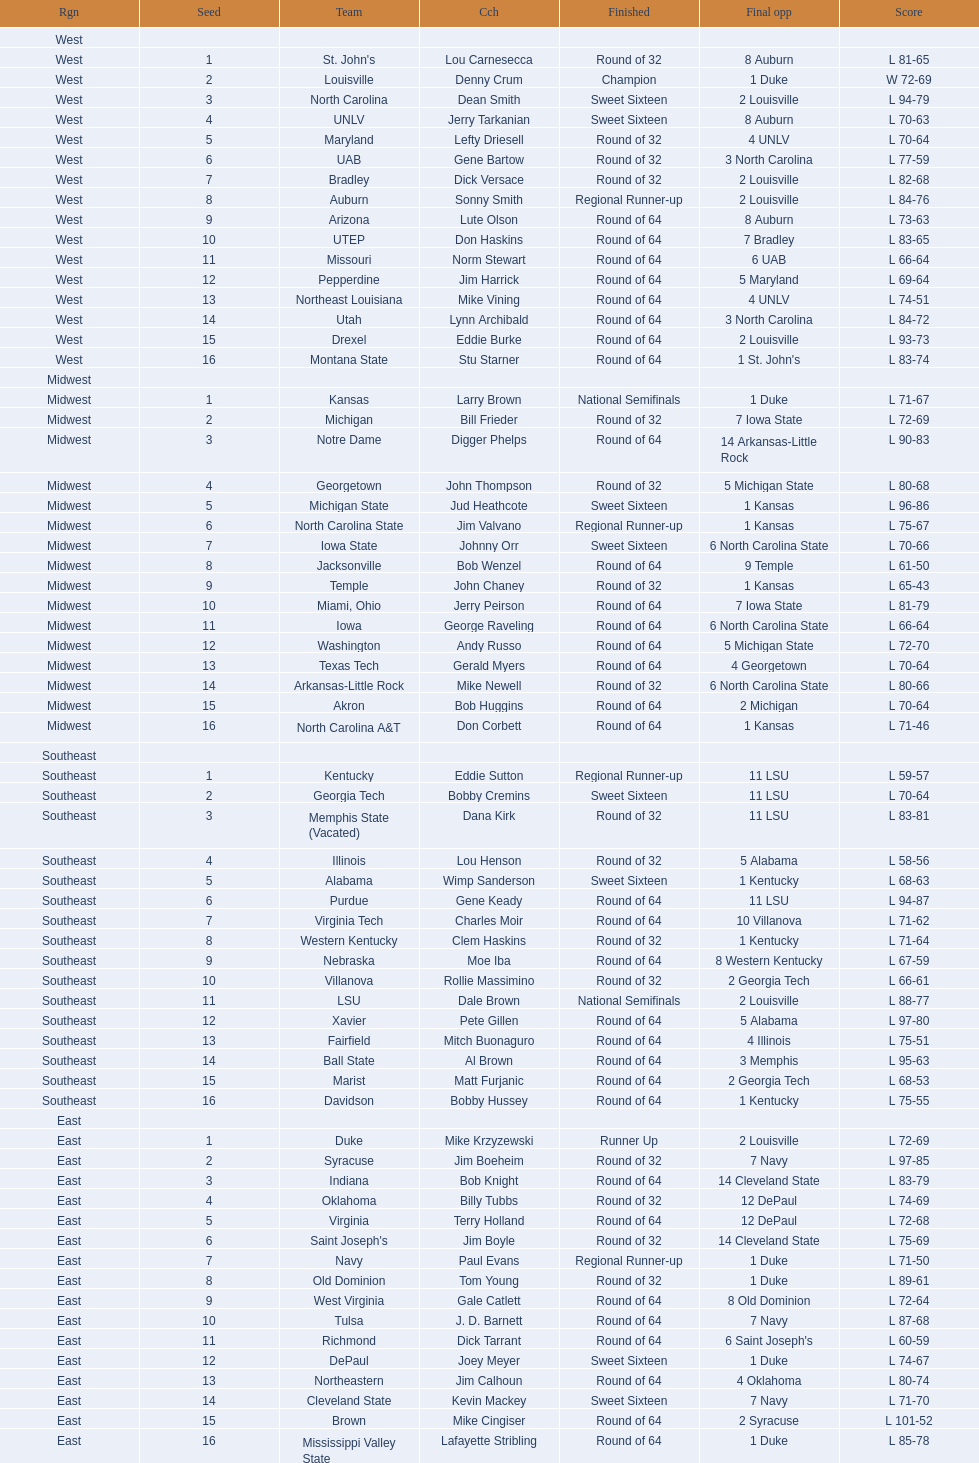Who was the only champion? Louisville. Parse the full table. {'header': ['Rgn', 'Seed', 'Team', 'Cch', 'Finished', 'Final opp', 'Score'], 'rows': [['West', '', '', '', '', '', ''], ['West', '1', "St. John's", 'Lou Carnesecca', 'Round of 32', '8 Auburn', 'L 81-65'], ['West', '2', 'Louisville', 'Denny Crum', 'Champion', '1 Duke', 'W 72-69'], ['West', '3', 'North Carolina', 'Dean Smith', 'Sweet Sixteen', '2 Louisville', 'L 94-79'], ['West', '4', 'UNLV', 'Jerry Tarkanian', 'Sweet Sixteen', '8 Auburn', 'L 70-63'], ['West', '5', 'Maryland', 'Lefty Driesell', 'Round of 32', '4 UNLV', 'L 70-64'], ['West', '6', 'UAB', 'Gene Bartow', 'Round of 32', '3 North Carolina', 'L 77-59'], ['West', '7', 'Bradley', 'Dick Versace', 'Round of 32', '2 Louisville', 'L 82-68'], ['West', '8', 'Auburn', 'Sonny Smith', 'Regional Runner-up', '2 Louisville', 'L 84-76'], ['West', '9', 'Arizona', 'Lute Olson', 'Round of 64', '8 Auburn', 'L 73-63'], ['West', '10', 'UTEP', 'Don Haskins', 'Round of 64', '7 Bradley', 'L 83-65'], ['West', '11', 'Missouri', 'Norm Stewart', 'Round of 64', '6 UAB', 'L 66-64'], ['West', '12', 'Pepperdine', 'Jim Harrick', 'Round of 64', '5 Maryland', 'L 69-64'], ['West', '13', 'Northeast Louisiana', 'Mike Vining', 'Round of 64', '4 UNLV', 'L 74-51'], ['West', '14', 'Utah', 'Lynn Archibald', 'Round of 64', '3 North Carolina', 'L 84-72'], ['West', '15', 'Drexel', 'Eddie Burke', 'Round of 64', '2 Louisville', 'L 93-73'], ['West', '16', 'Montana State', 'Stu Starner', 'Round of 64', "1 St. John's", 'L 83-74'], ['Midwest', '', '', '', '', '', ''], ['Midwest', '1', 'Kansas', 'Larry Brown', 'National Semifinals', '1 Duke', 'L 71-67'], ['Midwest', '2', 'Michigan', 'Bill Frieder', 'Round of 32', '7 Iowa State', 'L 72-69'], ['Midwest', '3', 'Notre Dame', 'Digger Phelps', 'Round of 64', '14 Arkansas-Little Rock', 'L 90-83'], ['Midwest', '4', 'Georgetown', 'John Thompson', 'Round of 32', '5 Michigan State', 'L 80-68'], ['Midwest', '5', 'Michigan State', 'Jud Heathcote', 'Sweet Sixteen', '1 Kansas', 'L 96-86'], ['Midwest', '6', 'North Carolina State', 'Jim Valvano', 'Regional Runner-up', '1 Kansas', 'L 75-67'], ['Midwest', '7', 'Iowa State', 'Johnny Orr', 'Sweet Sixteen', '6 North Carolina State', 'L 70-66'], ['Midwest', '8', 'Jacksonville', 'Bob Wenzel', 'Round of 64', '9 Temple', 'L 61-50'], ['Midwest', '9', 'Temple', 'John Chaney', 'Round of 32', '1 Kansas', 'L 65-43'], ['Midwest', '10', 'Miami, Ohio', 'Jerry Peirson', 'Round of 64', '7 Iowa State', 'L 81-79'], ['Midwest', '11', 'Iowa', 'George Raveling', 'Round of 64', '6 North Carolina State', 'L 66-64'], ['Midwest', '12', 'Washington', 'Andy Russo', 'Round of 64', '5 Michigan State', 'L 72-70'], ['Midwest', '13', 'Texas Tech', 'Gerald Myers', 'Round of 64', '4 Georgetown', 'L 70-64'], ['Midwest', '14', 'Arkansas-Little Rock', 'Mike Newell', 'Round of 32', '6 North Carolina State', 'L 80-66'], ['Midwest', '15', 'Akron', 'Bob Huggins', 'Round of 64', '2 Michigan', 'L 70-64'], ['Midwest', '16', 'North Carolina A&T', 'Don Corbett', 'Round of 64', '1 Kansas', 'L 71-46'], ['Southeast', '', '', '', '', '', ''], ['Southeast', '1', 'Kentucky', 'Eddie Sutton', 'Regional Runner-up', '11 LSU', 'L 59-57'], ['Southeast', '2', 'Georgia Tech', 'Bobby Cremins', 'Sweet Sixteen', '11 LSU', 'L 70-64'], ['Southeast', '3', 'Memphis State (Vacated)', 'Dana Kirk', 'Round of 32', '11 LSU', 'L 83-81'], ['Southeast', '4', 'Illinois', 'Lou Henson', 'Round of 32', '5 Alabama', 'L 58-56'], ['Southeast', '5', 'Alabama', 'Wimp Sanderson', 'Sweet Sixteen', '1 Kentucky', 'L 68-63'], ['Southeast', '6', 'Purdue', 'Gene Keady', 'Round of 64', '11 LSU', 'L 94-87'], ['Southeast', '7', 'Virginia Tech', 'Charles Moir', 'Round of 64', '10 Villanova', 'L 71-62'], ['Southeast', '8', 'Western Kentucky', 'Clem Haskins', 'Round of 32', '1 Kentucky', 'L 71-64'], ['Southeast', '9', 'Nebraska', 'Moe Iba', 'Round of 64', '8 Western Kentucky', 'L 67-59'], ['Southeast', '10', 'Villanova', 'Rollie Massimino', 'Round of 32', '2 Georgia Tech', 'L 66-61'], ['Southeast', '11', 'LSU', 'Dale Brown', 'National Semifinals', '2 Louisville', 'L 88-77'], ['Southeast', '12', 'Xavier', 'Pete Gillen', 'Round of 64', '5 Alabama', 'L 97-80'], ['Southeast', '13', 'Fairfield', 'Mitch Buonaguro', 'Round of 64', '4 Illinois', 'L 75-51'], ['Southeast', '14', 'Ball State', 'Al Brown', 'Round of 64', '3 Memphis', 'L 95-63'], ['Southeast', '15', 'Marist', 'Matt Furjanic', 'Round of 64', '2 Georgia Tech', 'L 68-53'], ['Southeast', '16', 'Davidson', 'Bobby Hussey', 'Round of 64', '1 Kentucky', 'L 75-55'], ['East', '', '', '', '', '', ''], ['East', '1', 'Duke', 'Mike Krzyzewski', 'Runner Up', '2 Louisville', 'L 72-69'], ['East', '2', 'Syracuse', 'Jim Boeheim', 'Round of 32', '7 Navy', 'L 97-85'], ['East', '3', 'Indiana', 'Bob Knight', 'Round of 64', '14 Cleveland State', 'L 83-79'], ['East', '4', 'Oklahoma', 'Billy Tubbs', 'Round of 32', '12 DePaul', 'L 74-69'], ['East', '5', 'Virginia', 'Terry Holland', 'Round of 64', '12 DePaul', 'L 72-68'], ['East', '6', "Saint Joseph's", 'Jim Boyle', 'Round of 32', '14 Cleveland State', 'L 75-69'], ['East', '7', 'Navy', 'Paul Evans', 'Regional Runner-up', '1 Duke', 'L 71-50'], ['East', '8', 'Old Dominion', 'Tom Young', 'Round of 32', '1 Duke', 'L 89-61'], ['East', '9', 'West Virginia', 'Gale Catlett', 'Round of 64', '8 Old Dominion', 'L 72-64'], ['East', '10', 'Tulsa', 'J. D. Barnett', 'Round of 64', '7 Navy', 'L 87-68'], ['East', '11', 'Richmond', 'Dick Tarrant', 'Round of 64', "6 Saint Joseph's", 'L 60-59'], ['East', '12', 'DePaul', 'Joey Meyer', 'Sweet Sixteen', '1 Duke', 'L 74-67'], ['East', '13', 'Northeastern', 'Jim Calhoun', 'Round of 64', '4 Oklahoma', 'L 80-74'], ['East', '14', 'Cleveland State', 'Kevin Mackey', 'Sweet Sixteen', '7 Navy', 'L 71-70'], ['East', '15', 'Brown', 'Mike Cingiser', 'Round of 64', '2 Syracuse', 'L 101-52'], ['East', '16', 'Mississippi Valley State', 'Lafayette Stribling', 'Round of 64', '1 Duke', 'L 85-78']]} 